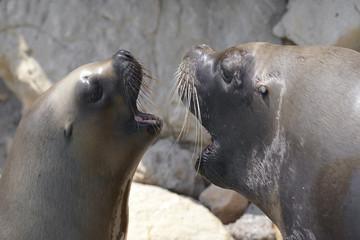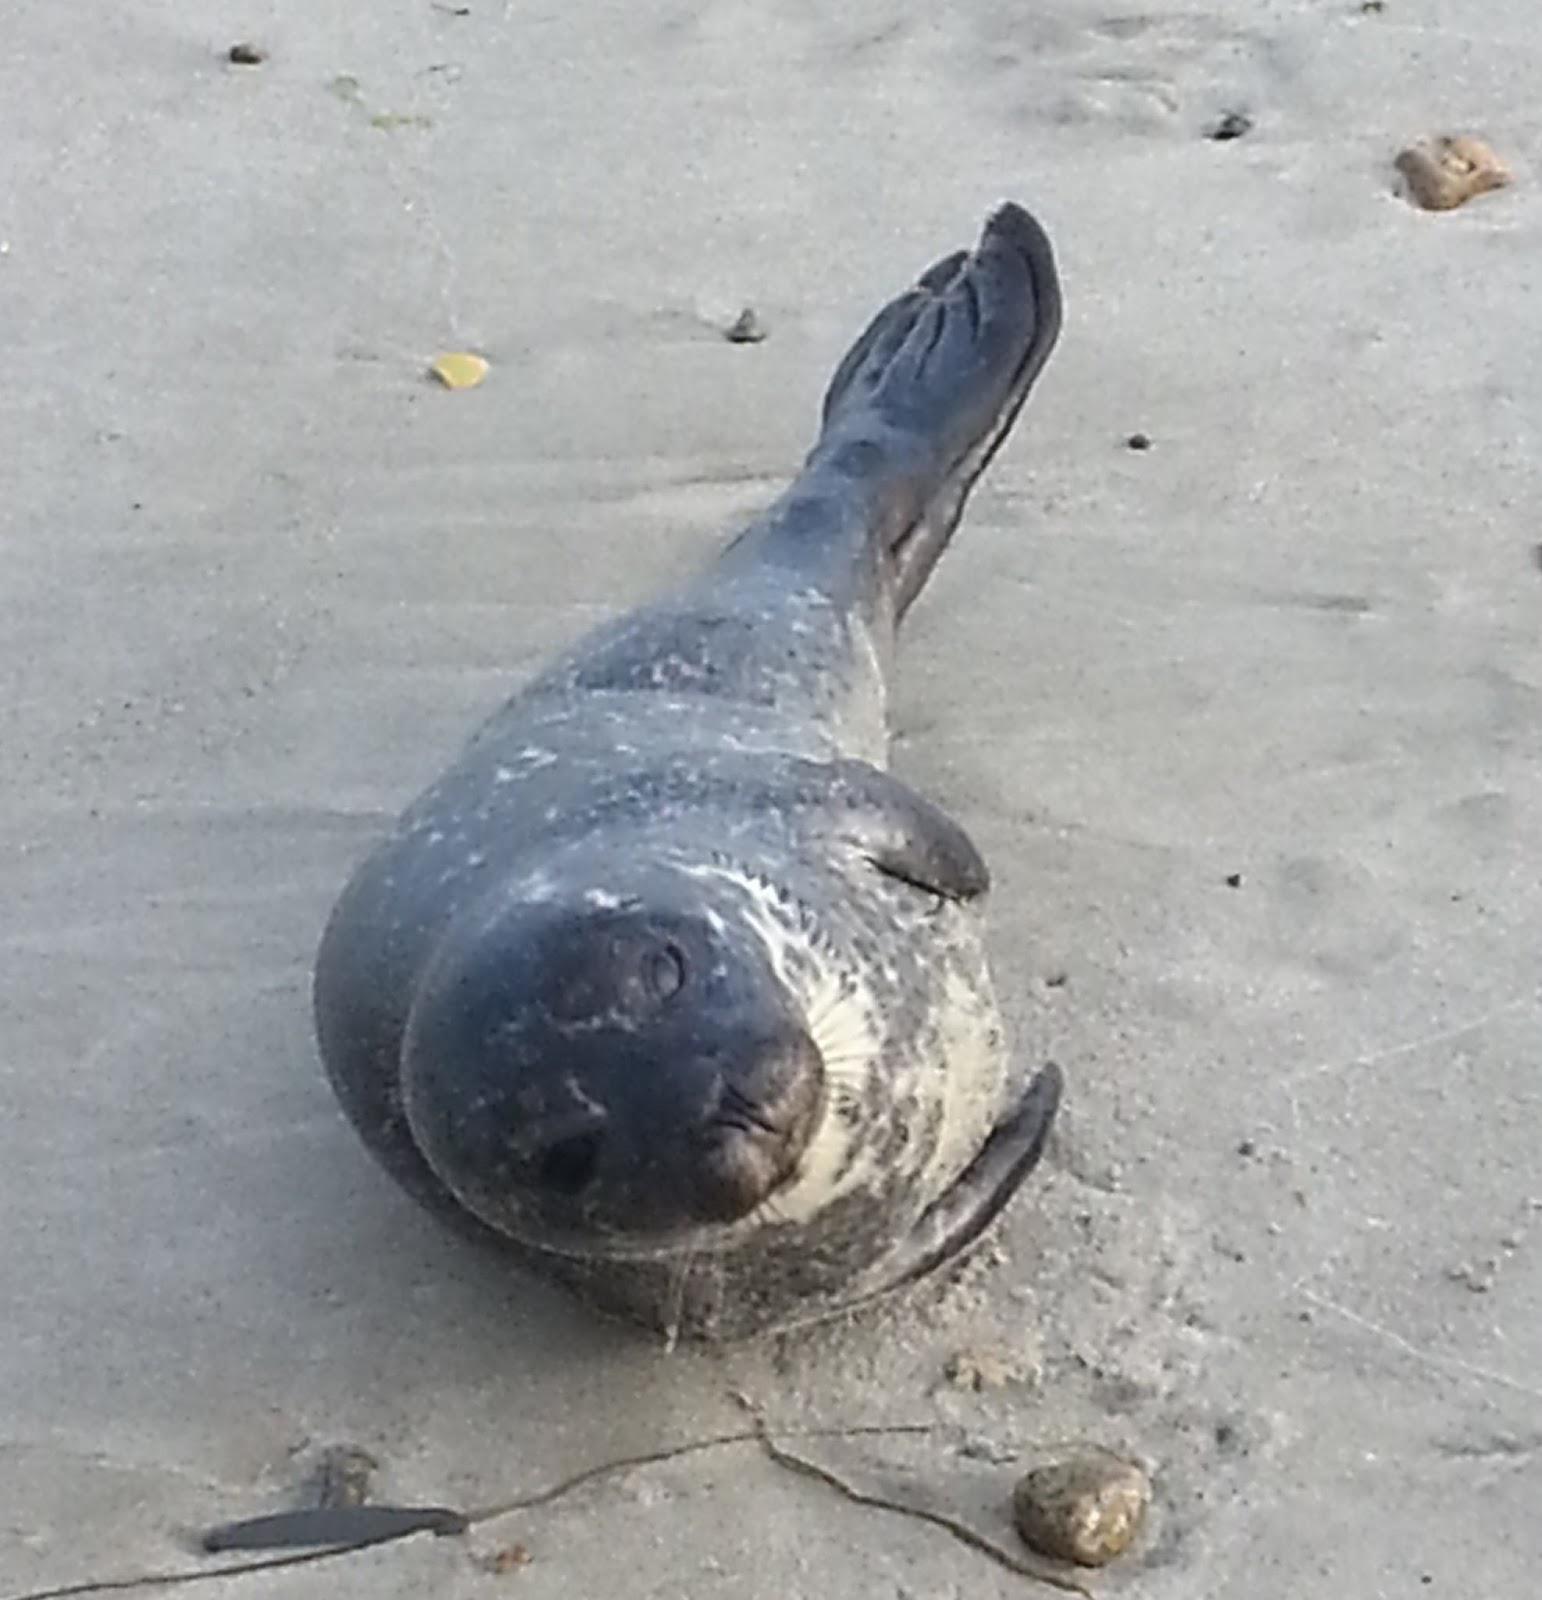The first image is the image on the left, the second image is the image on the right. For the images displayed, is the sentence "The right image contains two seals." factually correct? Answer yes or no. No. 